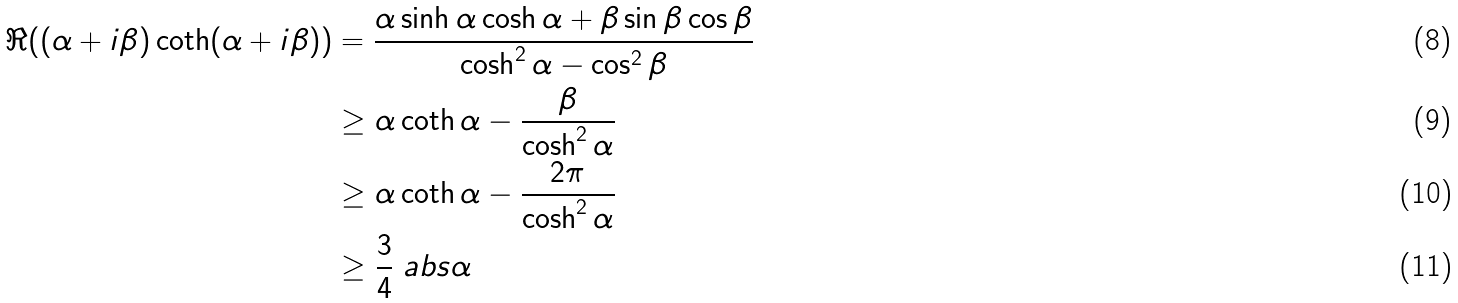<formula> <loc_0><loc_0><loc_500><loc_500>\Re ( ( \alpha + i \beta ) \coth ( \alpha + i \beta ) ) & = \frac { \alpha \sinh \alpha \cosh \alpha + \beta \sin \beta \cos \beta } { \cosh ^ { 2 } \alpha - \cos ^ { 2 } \beta } \\ & \geq \alpha \coth \alpha - \frac { \beta } { \cosh ^ { 2 } \alpha } \\ & \geq \alpha \coth \alpha - \frac { 2 \pi } { \cosh ^ { 2 } \alpha } \\ & \geq \frac { 3 } { 4 } \ a b s { \alpha }</formula> 